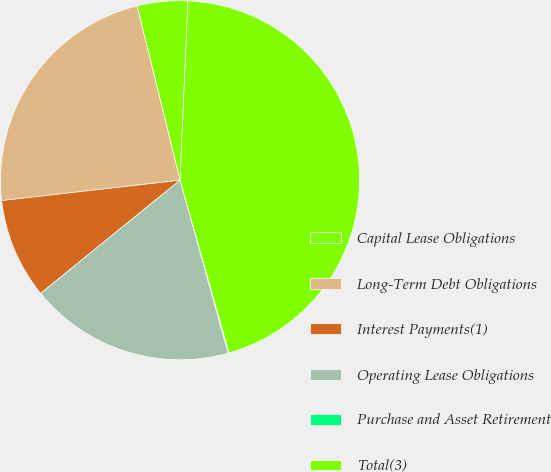Convert chart to OTSL. <chart><loc_0><loc_0><loc_500><loc_500><pie_chart><fcel>Capital Lease Obligations<fcel>Long-Term Debt Obligations<fcel>Interest Payments(1)<fcel>Operating Lease Obligations<fcel>Purchase and Asset Retirement<fcel>Total(3)<nl><fcel>4.56%<fcel>22.95%<fcel>9.04%<fcel>18.47%<fcel>0.08%<fcel>44.89%<nl></chart> 